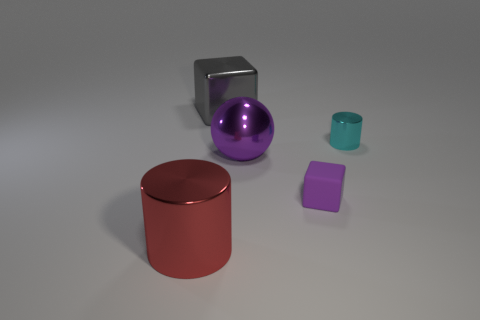Add 1 large gray things. How many objects exist? 6 Subtract all blocks. How many objects are left? 3 Add 4 gray metal blocks. How many gray metal blocks exist? 5 Subtract 1 cyan cylinders. How many objects are left? 4 Subtract all cyan shiny objects. Subtract all shiny cylinders. How many objects are left? 2 Add 2 purple spheres. How many purple spheres are left? 3 